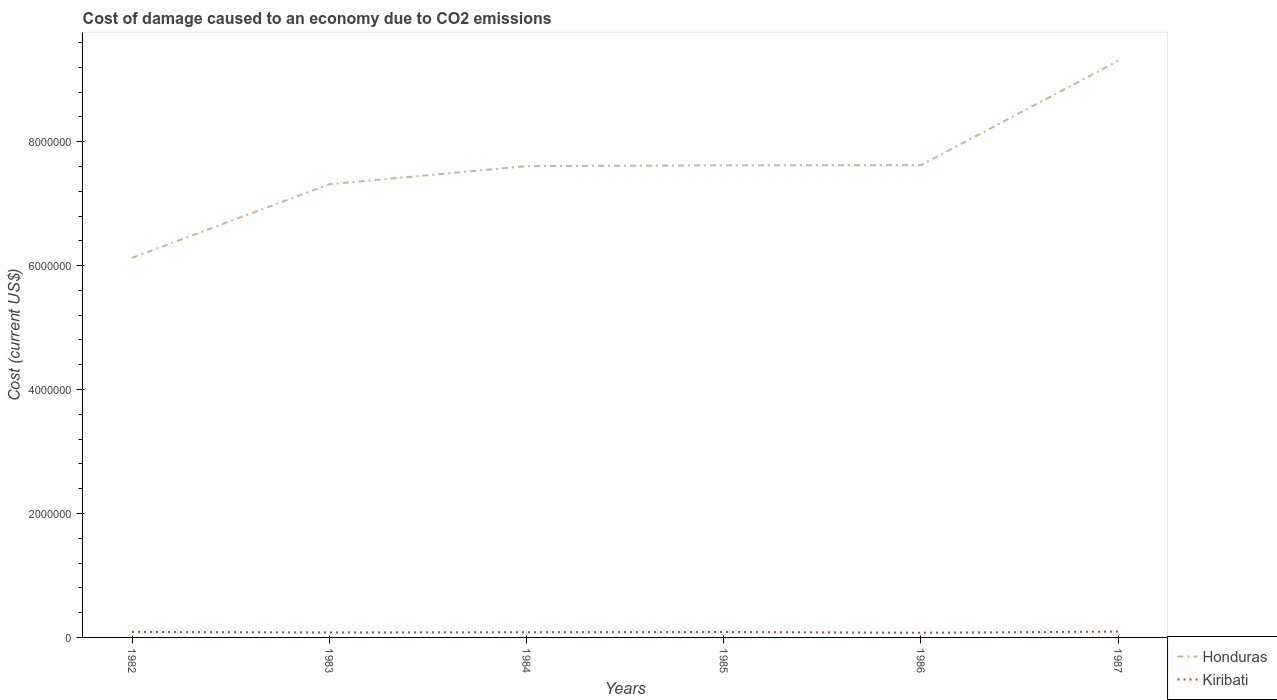How many different coloured lines are there?
Offer a terse response. 2. Does the line corresponding to Honduras intersect with the line corresponding to Kiribati?
Offer a terse response. No. Is the number of lines equal to the number of legend labels?
Make the answer very short. Yes. Across all years, what is the maximum cost of damage caused due to CO2 emissisons in Kiribati?
Your answer should be compact. 7.56e+04. In which year was the cost of damage caused due to CO2 emissisons in Honduras maximum?
Your answer should be very brief. 1982. What is the total cost of damage caused due to CO2 emissisons in Kiribati in the graph?
Provide a succinct answer. 1240.81. What is the difference between the highest and the second highest cost of damage caused due to CO2 emissisons in Kiribati?
Your answer should be compact. 1.85e+04. What is the difference between the highest and the lowest cost of damage caused due to CO2 emissisons in Honduras?
Provide a succinct answer. 4. What is the difference between two consecutive major ticks on the Y-axis?
Your response must be concise. 2.00e+06. Does the graph contain any zero values?
Your answer should be very brief. No. How many legend labels are there?
Offer a terse response. 2. What is the title of the graph?
Your answer should be very brief. Cost of damage caused to an economy due to CO2 emissions. What is the label or title of the Y-axis?
Offer a terse response. Cost (current US$). What is the Cost (current US$) of Honduras in 1982?
Make the answer very short. 6.13e+06. What is the Cost (current US$) of Kiribati in 1982?
Keep it short and to the point. 8.92e+04. What is the Cost (current US$) of Honduras in 1983?
Make the answer very short. 7.31e+06. What is the Cost (current US$) of Kiribati in 1983?
Keep it short and to the point. 8.04e+04. What is the Cost (current US$) in Honduras in 1984?
Your response must be concise. 7.61e+06. What is the Cost (current US$) of Kiribati in 1984?
Offer a very short reply. 8.42e+04. What is the Cost (current US$) in Honduras in 1985?
Provide a succinct answer. 7.62e+06. What is the Cost (current US$) in Kiribati in 1985?
Offer a terse response. 8.79e+04. What is the Cost (current US$) in Honduras in 1986?
Offer a terse response. 7.62e+06. What is the Cost (current US$) of Kiribati in 1986?
Your answer should be very brief. 7.56e+04. What is the Cost (current US$) in Honduras in 1987?
Give a very brief answer. 9.30e+06. What is the Cost (current US$) of Kiribati in 1987?
Keep it short and to the point. 9.41e+04. Across all years, what is the maximum Cost (current US$) of Honduras?
Offer a very short reply. 9.30e+06. Across all years, what is the maximum Cost (current US$) of Kiribati?
Your answer should be very brief. 9.41e+04. Across all years, what is the minimum Cost (current US$) in Honduras?
Offer a very short reply. 6.13e+06. Across all years, what is the minimum Cost (current US$) of Kiribati?
Your response must be concise. 7.56e+04. What is the total Cost (current US$) in Honduras in the graph?
Your response must be concise. 4.56e+07. What is the total Cost (current US$) in Kiribati in the graph?
Your response must be concise. 5.11e+05. What is the difference between the Cost (current US$) of Honduras in 1982 and that in 1983?
Ensure brevity in your answer.  -1.19e+06. What is the difference between the Cost (current US$) in Kiribati in 1982 and that in 1983?
Ensure brevity in your answer.  8785.17. What is the difference between the Cost (current US$) in Honduras in 1982 and that in 1984?
Your response must be concise. -1.48e+06. What is the difference between the Cost (current US$) of Kiribati in 1982 and that in 1984?
Your answer should be compact. 4955.95. What is the difference between the Cost (current US$) of Honduras in 1982 and that in 1985?
Offer a very short reply. -1.49e+06. What is the difference between the Cost (current US$) of Kiribati in 1982 and that in 1985?
Offer a very short reply. 1240.81. What is the difference between the Cost (current US$) of Honduras in 1982 and that in 1986?
Ensure brevity in your answer.  -1.50e+06. What is the difference between the Cost (current US$) in Kiribati in 1982 and that in 1986?
Give a very brief answer. 1.35e+04. What is the difference between the Cost (current US$) of Honduras in 1982 and that in 1987?
Offer a very short reply. -3.18e+06. What is the difference between the Cost (current US$) of Kiribati in 1982 and that in 1987?
Provide a short and direct response. -4995.06. What is the difference between the Cost (current US$) in Honduras in 1983 and that in 1984?
Your response must be concise. -2.92e+05. What is the difference between the Cost (current US$) in Kiribati in 1983 and that in 1984?
Offer a terse response. -3829.22. What is the difference between the Cost (current US$) in Honduras in 1983 and that in 1985?
Offer a very short reply. -3.06e+05. What is the difference between the Cost (current US$) of Kiribati in 1983 and that in 1985?
Provide a short and direct response. -7544.36. What is the difference between the Cost (current US$) of Honduras in 1983 and that in 1986?
Provide a succinct answer. -3.09e+05. What is the difference between the Cost (current US$) of Kiribati in 1983 and that in 1986?
Keep it short and to the point. 4751.38. What is the difference between the Cost (current US$) of Honduras in 1983 and that in 1987?
Make the answer very short. -1.99e+06. What is the difference between the Cost (current US$) of Kiribati in 1983 and that in 1987?
Your answer should be compact. -1.38e+04. What is the difference between the Cost (current US$) of Honduras in 1984 and that in 1985?
Ensure brevity in your answer.  -1.33e+04. What is the difference between the Cost (current US$) in Kiribati in 1984 and that in 1985?
Offer a terse response. -3715.14. What is the difference between the Cost (current US$) of Honduras in 1984 and that in 1986?
Provide a succinct answer. -1.63e+04. What is the difference between the Cost (current US$) in Kiribati in 1984 and that in 1986?
Provide a short and direct response. 8580.59. What is the difference between the Cost (current US$) of Honduras in 1984 and that in 1987?
Give a very brief answer. -1.70e+06. What is the difference between the Cost (current US$) in Kiribati in 1984 and that in 1987?
Provide a succinct answer. -9951.01. What is the difference between the Cost (current US$) of Honduras in 1985 and that in 1986?
Your response must be concise. -3065.35. What is the difference between the Cost (current US$) in Kiribati in 1985 and that in 1986?
Offer a very short reply. 1.23e+04. What is the difference between the Cost (current US$) of Honduras in 1985 and that in 1987?
Offer a very short reply. -1.69e+06. What is the difference between the Cost (current US$) in Kiribati in 1985 and that in 1987?
Your response must be concise. -6235.87. What is the difference between the Cost (current US$) in Honduras in 1986 and that in 1987?
Keep it short and to the point. -1.68e+06. What is the difference between the Cost (current US$) in Kiribati in 1986 and that in 1987?
Provide a succinct answer. -1.85e+04. What is the difference between the Cost (current US$) in Honduras in 1982 and the Cost (current US$) in Kiribati in 1983?
Your answer should be compact. 6.05e+06. What is the difference between the Cost (current US$) in Honduras in 1982 and the Cost (current US$) in Kiribati in 1984?
Your response must be concise. 6.04e+06. What is the difference between the Cost (current US$) in Honduras in 1982 and the Cost (current US$) in Kiribati in 1985?
Offer a very short reply. 6.04e+06. What is the difference between the Cost (current US$) of Honduras in 1982 and the Cost (current US$) of Kiribati in 1986?
Your answer should be very brief. 6.05e+06. What is the difference between the Cost (current US$) of Honduras in 1982 and the Cost (current US$) of Kiribati in 1987?
Ensure brevity in your answer.  6.03e+06. What is the difference between the Cost (current US$) of Honduras in 1983 and the Cost (current US$) of Kiribati in 1984?
Offer a terse response. 7.23e+06. What is the difference between the Cost (current US$) in Honduras in 1983 and the Cost (current US$) in Kiribati in 1985?
Offer a very short reply. 7.23e+06. What is the difference between the Cost (current US$) of Honduras in 1983 and the Cost (current US$) of Kiribati in 1986?
Offer a terse response. 7.24e+06. What is the difference between the Cost (current US$) of Honduras in 1983 and the Cost (current US$) of Kiribati in 1987?
Your answer should be compact. 7.22e+06. What is the difference between the Cost (current US$) in Honduras in 1984 and the Cost (current US$) in Kiribati in 1985?
Provide a succinct answer. 7.52e+06. What is the difference between the Cost (current US$) in Honduras in 1984 and the Cost (current US$) in Kiribati in 1986?
Make the answer very short. 7.53e+06. What is the difference between the Cost (current US$) of Honduras in 1984 and the Cost (current US$) of Kiribati in 1987?
Your answer should be very brief. 7.51e+06. What is the difference between the Cost (current US$) in Honduras in 1985 and the Cost (current US$) in Kiribati in 1986?
Your answer should be very brief. 7.54e+06. What is the difference between the Cost (current US$) of Honduras in 1985 and the Cost (current US$) of Kiribati in 1987?
Make the answer very short. 7.52e+06. What is the difference between the Cost (current US$) of Honduras in 1986 and the Cost (current US$) of Kiribati in 1987?
Provide a succinct answer. 7.53e+06. What is the average Cost (current US$) of Honduras per year?
Give a very brief answer. 7.60e+06. What is the average Cost (current US$) in Kiribati per year?
Offer a terse response. 8.52e+04. In the year 1982, what is the difference between the Cost (current US$) in Honduras and Cost (current US$) in Kiribati?
Ensure brevity in your answer.  6.04e+06. In the year 1983, what is the difference between the Cost (current US$) of Honduras and Cost (current US$) of Kiribati?
Offer a terse response. 7.23e+06. In the year 1984, what is the difference between the Cost (current US$) in Honduras and Cost (current US$) in Kiribati?
Your answer should be compact. 7.52e+06. In the year 1985, what is the difference between the Cost (current US$) in Honduras and Cost (current US$) in Kiribati?
Provide a short and direct response. 7.53e+06. In the year 1986, what is the difference between the Cost (current US$) of Honduras and Cost (current US$) of Kiribati?
Ensure brevity in your answer.  7.55e+06. In the year 1987, what is the difference between the Cost (current US$) in Honduras and Cost (current US$) in Kiribati?
Give a very brief answer. 9.21e+06. What is the ratio of the Cost (current US$) in Honduras in 1982 to that in 1983?
Your response must be concise. 0.84. What is the ratio of the Cost (current US$) in Kiribati in 1982 to that in 1983?
Provide a short and direct response. 1.11. What is the ratio of the Cost (current US$) in Honduras in 1982 to that in 1984?
Give a very brief answer. 0.81. What is the ratio of the Cost (current US$) of Kiribati in 1982 to that in 1984?
Keep it short and to the point. 1.06. What is the ratio of the Cost (current US$) in Honduras in 1982 to that in 1985?
Ensure brevity in your answer.  0.8. What is the ratio of the Cost (current US$) of Kiribati in 1982 to that in 1985?
Ensure brevity in your answer.  1.01. What is the ratio of the Cost (current US$) of Honduras in 1982 to that in 1986?
Your response must be concise. 0.8. What is the ratio of the Cost (current US$) in Kiribati in 1982 to that in 1986?
Provide a short and direct response. 1.18. What is the ratio of the Cost (current US$) of Honduras in 1982 to that in 1987?
Provide a succinct answer. 0.66. What is the ratio of the Cost (current US$) in Kiribati in 1982 to that in 1987?
Provide a succinct answer. 0.95. What is the ratio of the Cost (current US$) in Honduras in 1983 to that in 1984?
Your response must be concise. 0.96. What is the ratio of the Cost (current US$) of Kiribati in 1983 to that in 1984?
Provide a short and direct response. 0.95. What is the ratio of the Cost (current US$) in Honduras in 1983 to that in 1985?
Your response must be concise. 0.96. What is the ratio of the Cost (current US$) of Kiribati in 1983 to that in 1985?
Offer a very short reply. 0.91. What is the ratio of the Cost (current US$) in Honduras in 1983 to that in 1986?
Provide a short and direct response. 0.96. What is the ratio of the Cost (current US$) of Kiribati in 1983 to that in 1986?
Ensure brevity in your answer.  1.06. What is the ratio of the Cost (current US$) of Honduras in 1983 to that in 1987?
Provide a succinct answer. 0.79. What is the ratio of the Cost (current US$) of Kiribati in 1983 to that in 1987?
Your answer should be very brief. 0.85. What is the ratio of the Cost (current US$) of Kiribati in 1984 to that in 1985?
Give a very brief answer. 0.96. What is the ratio of the Cost (current US$) of Honduras in 1984 to that in 1986?
Your answer should be very brief. 1. What is the ratio of the Cost (current US$) in Kiribati in 1984 to that in 1986?
Give a very brief answer. 1.11. What is the ratio of the Cost (current US$) of Honduras in 1984 to that in 1987?
Ensure brevity in your answer.  0.82. What is the ratio of the Cost (current US$) in Kiribati in 1984 to that in 1987?
Keep it short and to the point. 0.89. What is the ratio of the Cost (current US$) of Kiribati in 1985 to that in 1986?
Provide a succinct answer. 1.16. What is the ratio of the Cost (current US$) in Honduras in 1985 to that in 1987?
Keep it short and to the point. 0.82. What is the ratio of the Cost (current US$) in Kiribati in 1985 to that in 1987?
Offer a very short reply. 0.93. What is the ratio of the Cost (current US$) of Honduras in 1986 to that in 1987?
Your answer should be compact. 0.82. What is the ratio of the Cost (current US$) in Kiribati in 1986 to that in 1987?
Your answer should be compact. 0.8. What is the difference between the highest and the second highest Cost (current US$) of Honduras?
Your answer should be compact. 1.68e+06. What is the difference between the highest and the second highest Cost (current US$) in Kiribati?
Your answer should be compact. 4995.06. What is the difference between the highest and the lowest Cost (current US$) in Honduras?
Ensure brevity in your answer.  3.18e+06. What is the difference between the highest and the lowest Cost (current US$) of Kiribati?
Your answer should be very brief. 1.85e+04. 